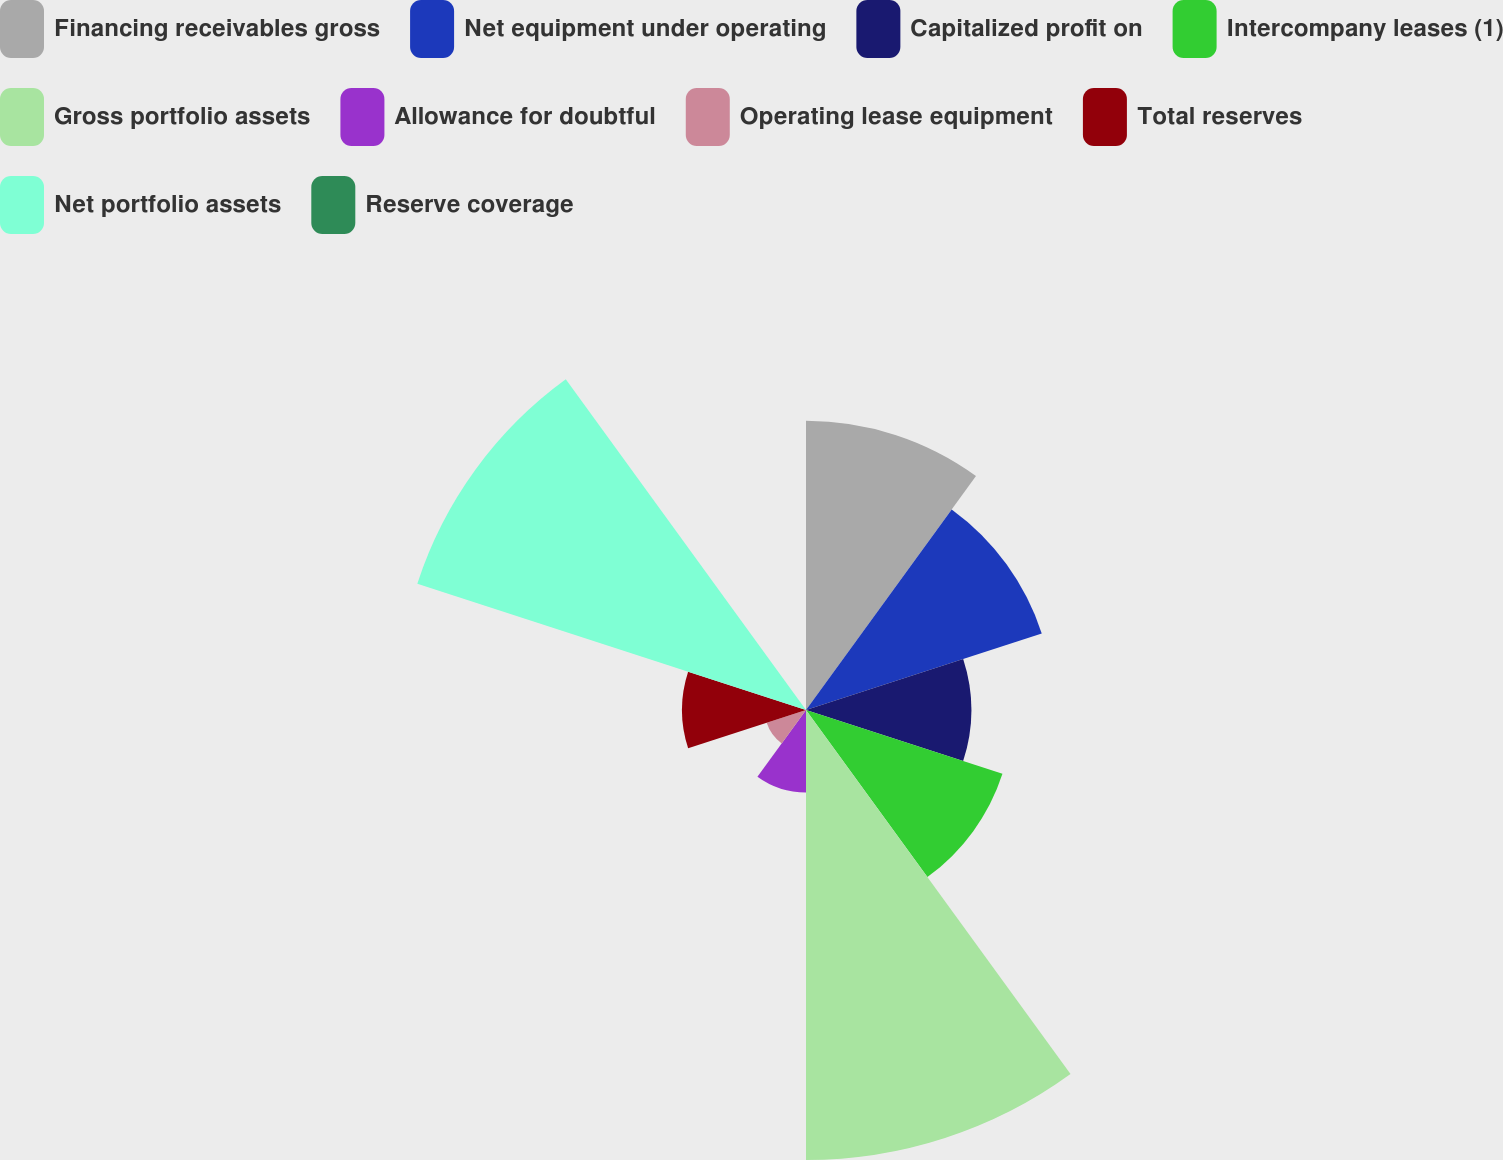Convert chart. <chart><loc_0><loc_0><loc_500><loc_500><pie_chart><fcel>Financing receivables gross<fcel>Net equipment under operating<fcel>Capitalized profit on<fcel>Intercompany leases (1)<fcel>Gross portfolio assets<fcel>Allowance for doubtful<fcel>Operating lease equipment<fcel>Total reserves<fcel>Net portfolio assets<fcel>Reserve coverage<nl><fcel>14.35%<fcel>12.3%<fcel>8.2%<fcel>10.25%<fcel>22.33%<fcel>4.1%<fcel>2.05%<fcel>6.15%<fcel>20.28%<fcel>0.0%<nl></chart> 